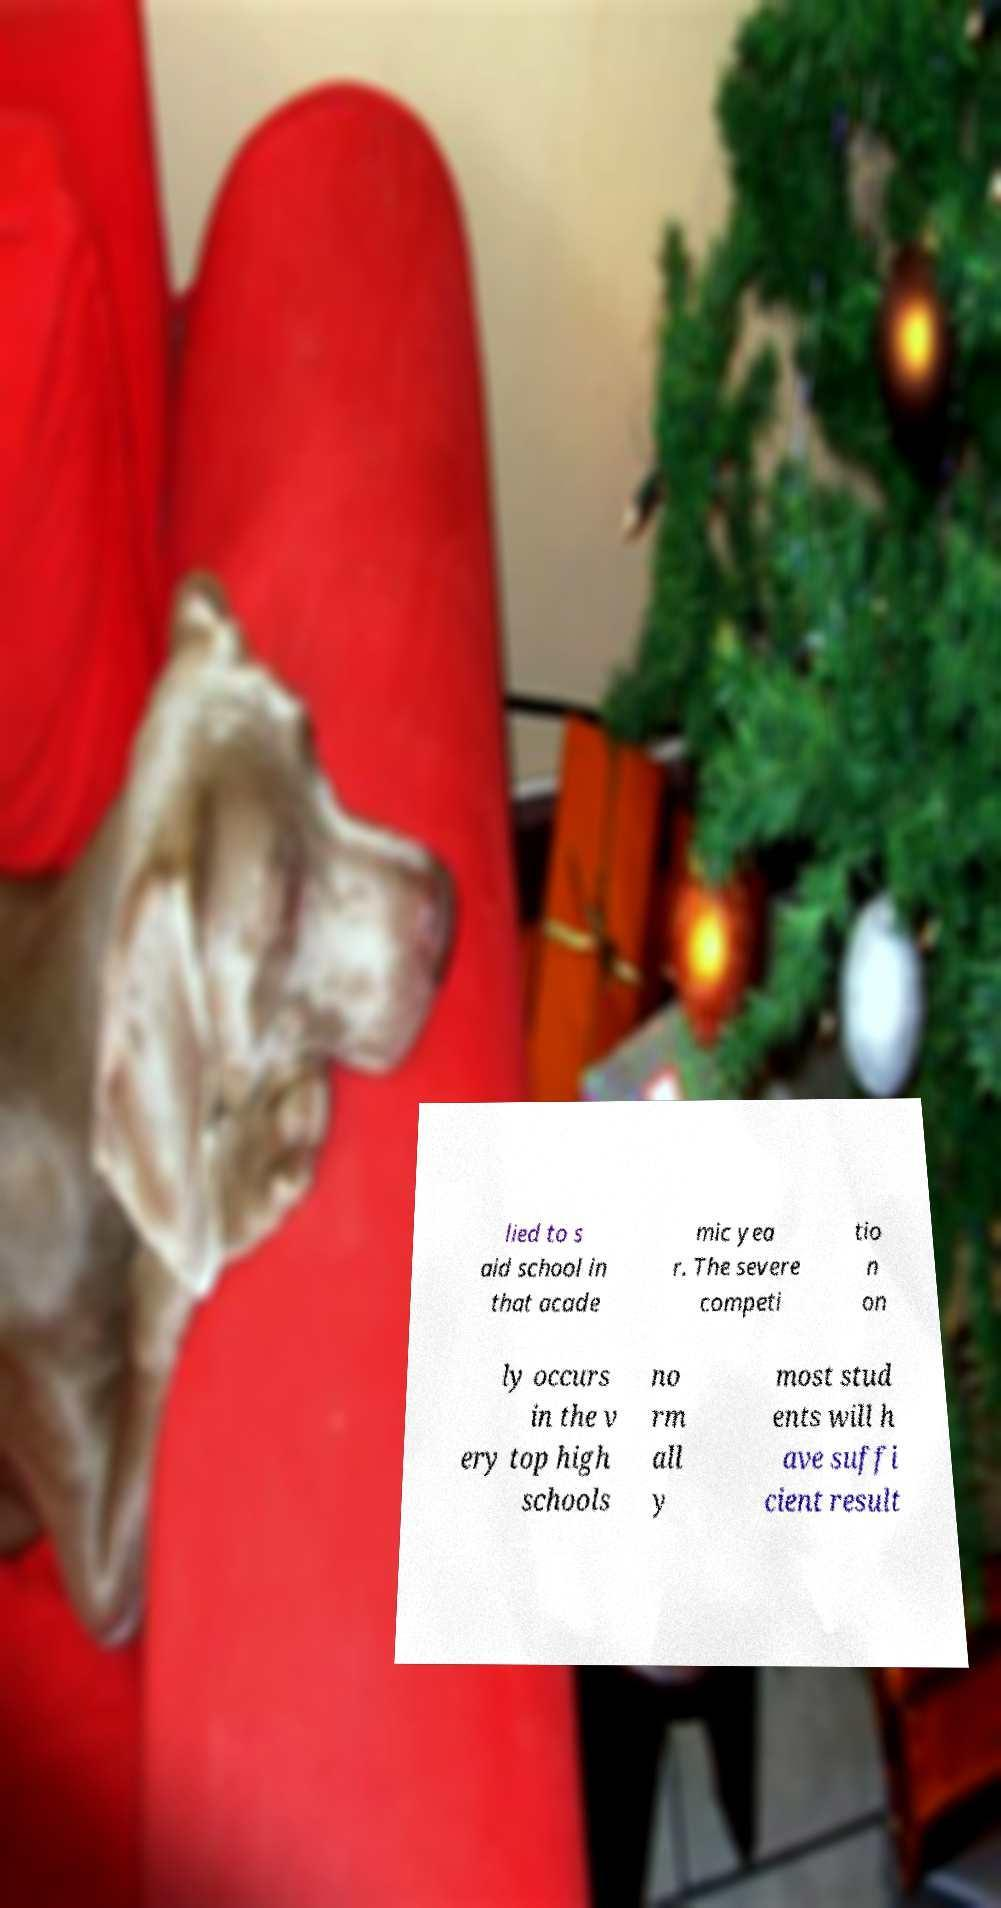Please identify and transcribe the text found in this image. lied to s aid school in that acade mic yea r. The severe competi tio n on ly occurs in the v ery top high schools no rm all y most stud ents will h ave suffi cient result 